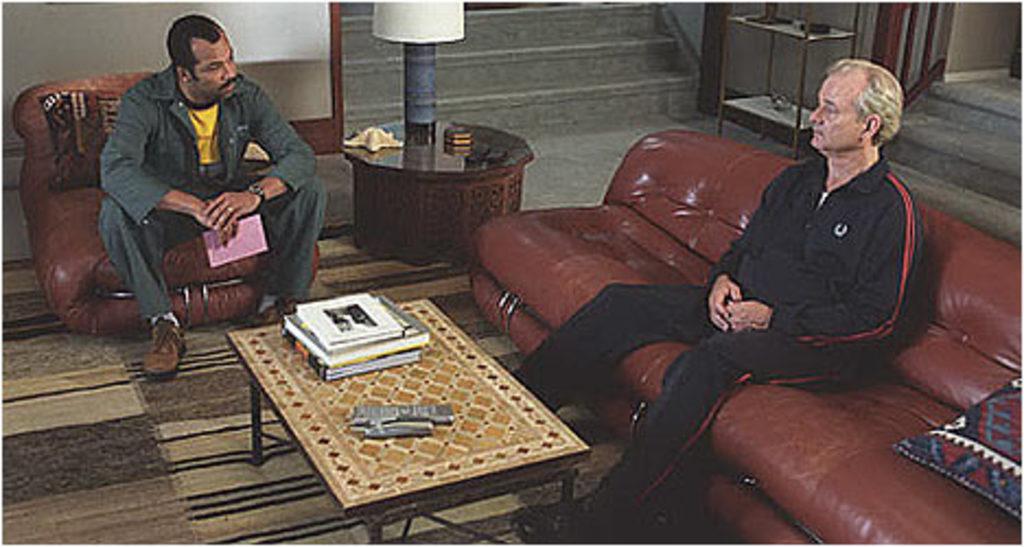How would you summarize this image in a sentence or two? In this image I see 2 men who are sitting on sofa and this man is holding a paper, I see a table in front of them on which there are books and other thing. I can also see stairs over here and here too and I see the wall. 